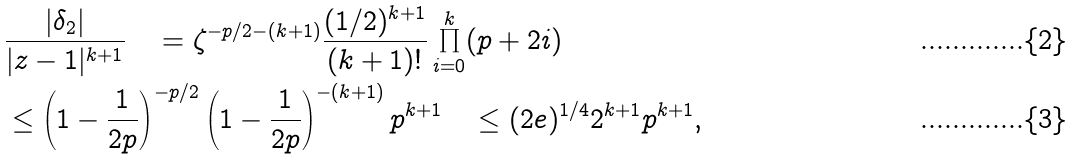<formula> <loc_0><loc_0><loc_500><loc_500>& \frac { | \delta _ { 2 } | } { | z - 1 | ^ { k + 1 } } \quad = \zeta ^ { - p / 2 - ( k + 1 ) } \frac { ( 1 / 2 ) ^ { k + 1 } } { ( k + 1 ) ! } \prod _ { i = 0 } ^ { k } ( p + 2 i ) \\ & \leq \left ( 1 - \frac { 1 } { 2 p } \right ) ^ { - p / 2 } \left ( 1 - \frac { 1 } { 2 p } \right ) ^ { - ( k + 1 ) } p ^ { k + 1 } \quad \leq ( 2 e ) ^ { 1 / 4 } 2 ^ { k + 1 } p ^ { k + 1 } ,</formula> 